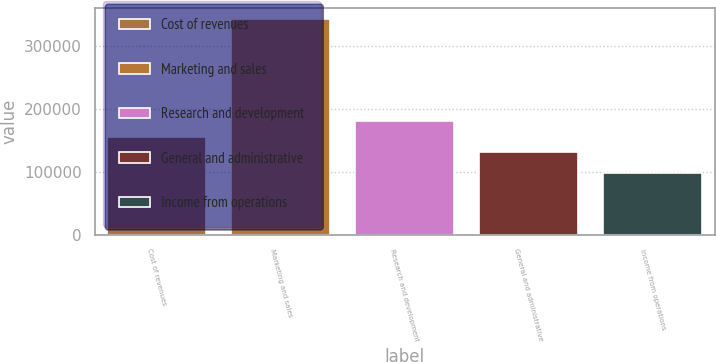Convert chart to OTSL. <chart><loc_0><loc_0><loc_500><loc_500><bar_chart><fcel>Cost of revenues<fcel>Marketing and sales<fcel>Research and development<fcel>General and administrative<fcel>Income from operations<nl><fcel>156032<fcel>343508<fcel>180566<fcel>131499<fcel>98174<nl></chart> 